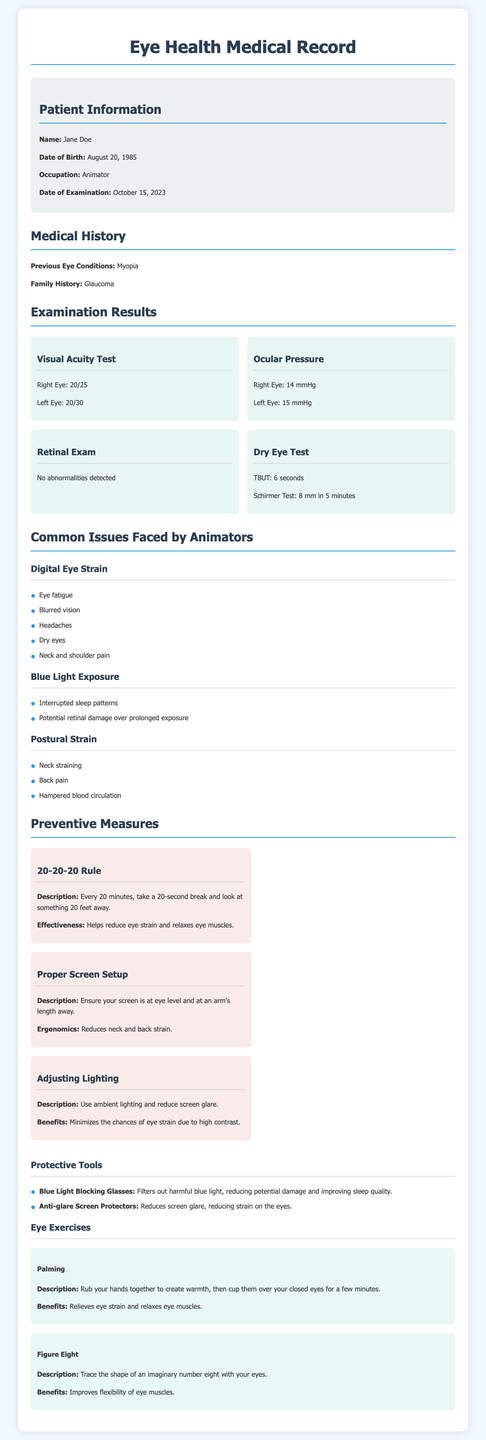What is the name of the patient? The name of the patient is mentioned in the patient information section of the document.
Answer: Jane Doe What are the visual acuity test results for the left eye? The visual acuity test results for the left eye are provided under the examination results section.
Answer: 20/30 What is the date of examination? The date of examination can be found in the patient information section of the document.
Answer: October 15, 2023 What is the primary occupation of the patient? The occupation of the patient is stated under the patient information section.
Answer: Animator What is a common issue faced by animators due to prolonged screen time? Common issues are listed in the document's section about common issues faced by animators.
Answer: Eye fatigue What is the effectiveness of the 20-20-20 rule? The effectiveness of the 20-20-20 rule is described in the preventive measures section of the document.
Answer: Helps reduce eye strain and relaxes eye muscles How many seconds does the TBUT indicate in the dry eye test? The TBUT result is stated in the examination results section under the dry eye test.
Answer: 6 seconds What type of glasses is recommended to filter out harmful blue light? The document provides recommendations for protective tools specifically for eye health.
Answer: Blue Light Blocking Glasses What exercise helps to improve flexibility of eye muscles? The exercise is mentioned under the eye exercises section of the document.
Answer: Figure Eight 